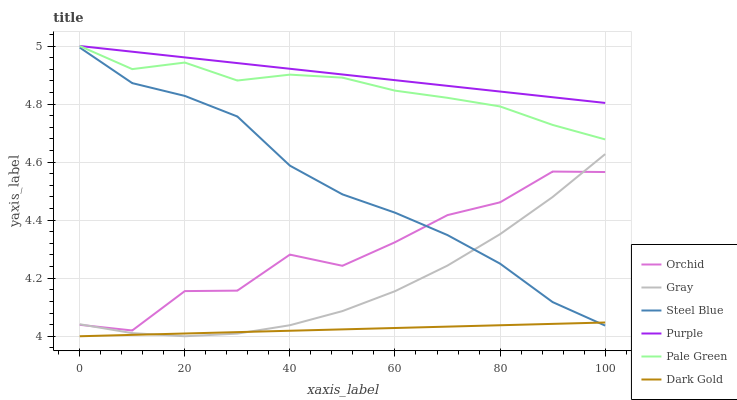Does Purple have the minimum area under the curve?
Answer yes or no. No. Does Dark Gold have the maximum area under the curve?
Answer yes or no. No. Is Purple the smoothest?
Answer yes or no. No. Is Purple the roughest?
Answer yes or no. No. Does Purple have the lowest value?
Answer yes or no. No. Does Dark Gold have the highest value?
Answer yes or no. No. Is Dark Gold less than Orchid?
Answer yes or no. Yes. Is Purple greater than Orchid?
Answer yes or no. Yes. Does Dark Gold intersect Orchid?
Answer yes or no. No. 